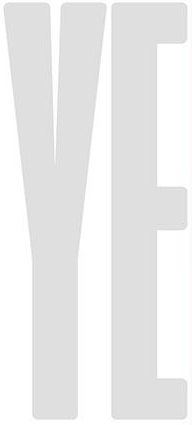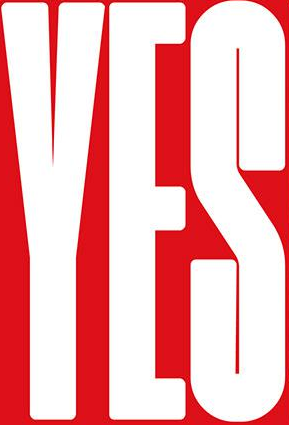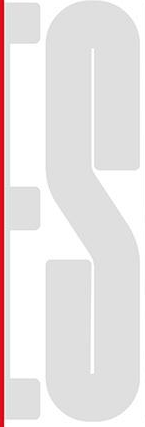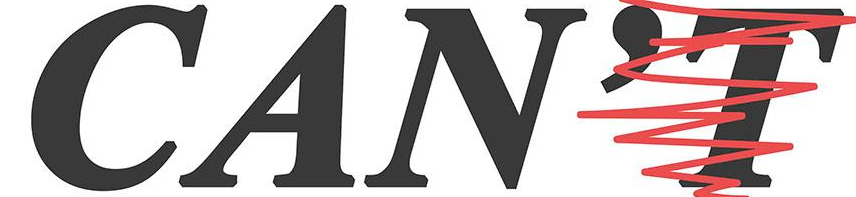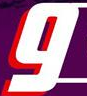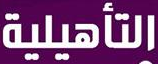What words can you see in these images in sequence, separated by a semicolon? YE; YES; ES; CAN'T; g; ### 